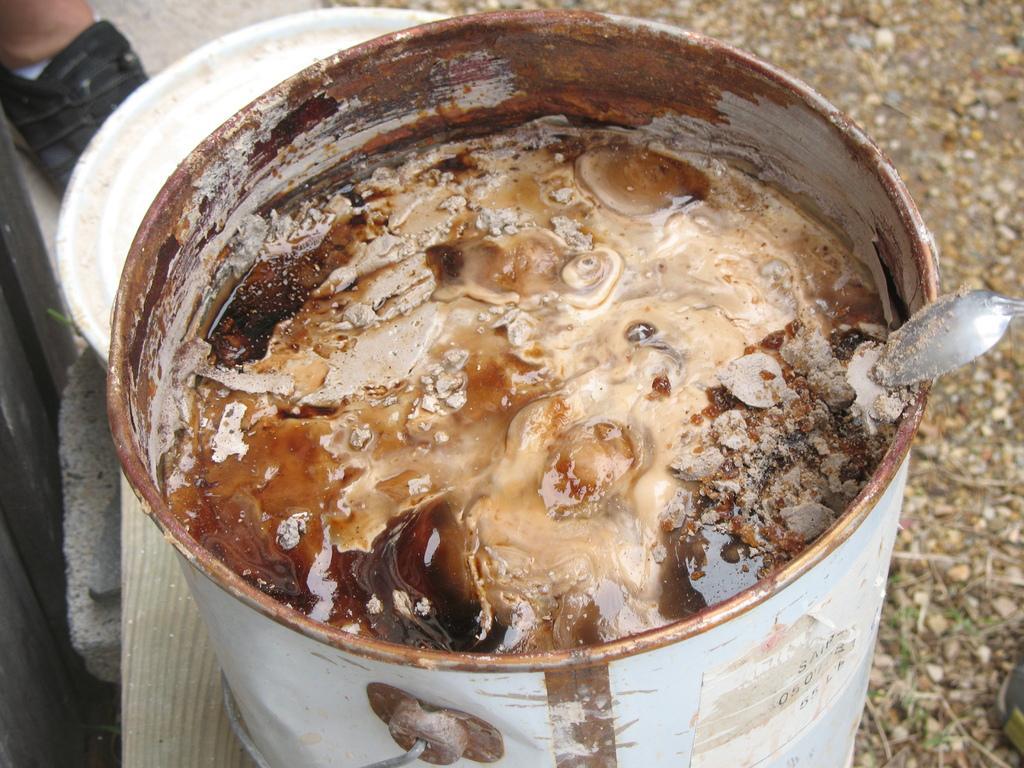In one or two sentences, can you explain what this image depicts? In the foreground I can see a bowl, vessel in which I can see a cream like paint. In the background I can see a person's leg and a spoon. This image is taken may be during a day. 